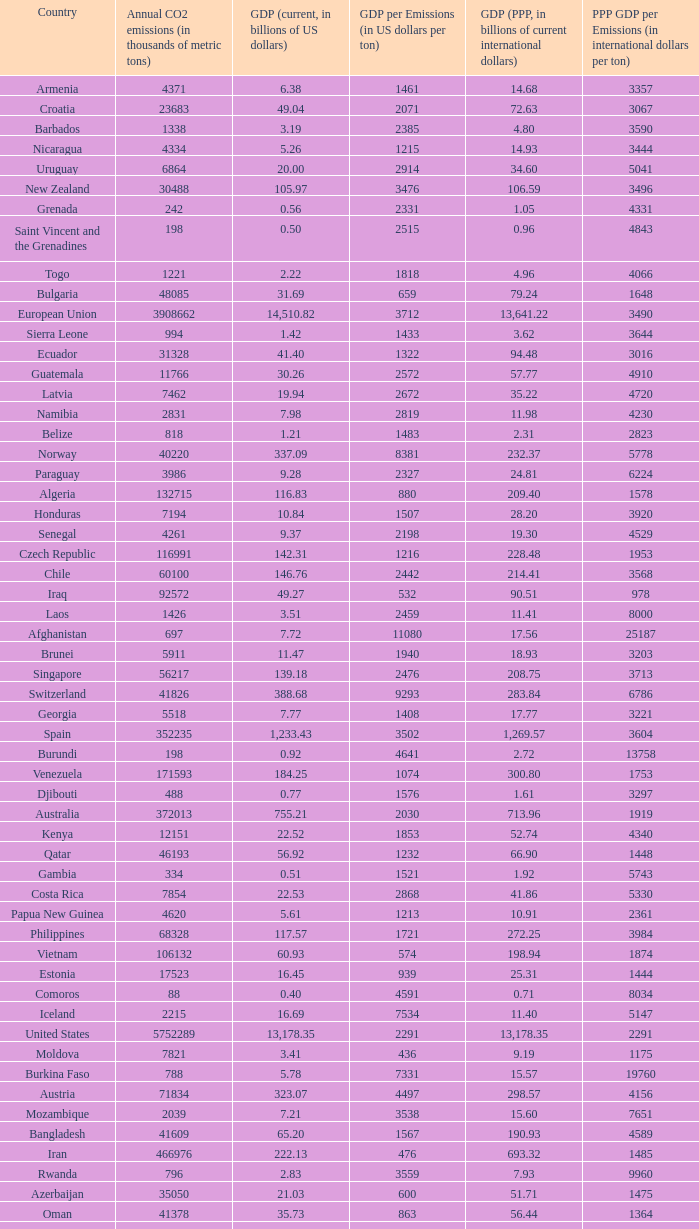Parse the full table. {'header': ['Country', 'Annual CO2 emissions (in thousands of metric tons)', 'GDP (current, in billions of US dollars)', 'GDP per Emissions (in US dollars per ton)', 'GDP (PPP, in billions of current international dollars)', 'PPP GDP per Emissions (in international dollars per ton)'], 'rows': [['Armenia', '4371', '6.38', '1461', '14.68', '3357'], ['Croatia', '23683', '49.04', '2071', '72.63', '3067'], ['Barbados', '1338', '3.19', '2385', '4.80', '3590'], ['Nicaragua', '4334', '5.26', '1215', '14.93', '3444'], ['Uruguay', '6864', '20.00', '2914', '34.60', '5041'], ['New Zealand', '30488', '105.97', '3476', '106.59', '3496'], ['Grenada', '242', '0.56', '2331', '1.05', '4331'], ['Saint Vincent and the Grenadines', '198', '0.50', '2515', '0.96', '4843'], ['Togo', '1221', '2.22', '1818', '4.96', '4066'], ['Bulgaria', '48085', '31.69', '659', '79.24', '1648'], ['European Union', '3908662', '14,510.82', '3712', '13,641.22', '3490'], ['Sierra Leone', '994', '1.42', '1433', '3.62', '3644'], ['Ecuador', '31328', '41.40', '1322', '94.48', '3016'], ['Guatemala', '11766', '30.26', '2572', '57.77', '4910'], ['Latvia', '7462', '19.94', '2672', '35.22', '4720'], ['Namibia', '2831', '7.98', '2819', '11.98', '4230'], ['Belize', '818', '1.21', '1483', '2.31', '2823'], ['Norway', '40220', '337.09', '8381', '232.37', '5778'], ['Paraguay', '3986', '9.28', '2327', '24.81', '6224'], ['Algeria', '132715', '116.83', '880', '209.40', '1578'], ['Honduras', '7194', '10.84', '1507', '28.20', '3920'], ['Senegal', '4261', '9.37', '2198', '19.30', '4529'], ['Czech Republic', '116991', '142.31', '1216', '228.48', '1953'], ['Chile', '60100', '146.76', '2442', '214.41', '3568'], ['Iraq', '92572', '49.27', '532', '90.51', '978'], ['Laos', '1426', '3.51', '2459', '11.41', '8000'], ['Afghanistan', '697', '7.72', '11080', '17.56', '25187'], ['Brunei', '5911', '11.47', '1940', '18.93', '3203'], ['Singapore', '56217', '139.18', '2476', '208.75', '3713'], ['Switzerland', '41826', '388.68', '9293', '283.84', '6786'], ['Georgia', '5518', '7.77', '1408', '17.77', '3221'], ['Spain', '352235', '1,233.43', '3502', '1,269.57', '3604'], ['Burundi', '198', '0.92', '4641', '2.72', '13758'], ['Venezuela', '171593', '184.25', '1074', '300.80', '1753'], ['Djibouti', '488', '0.77', '1576', '1.61', '3297'], ['Australia', '372013', '755.21', '2030', '713.96', '1919'], ['Kenya', '12151', '22.52', '1853', '52.74', '4340'], ['Qatar', '46193', '56.92', '1232', '66.90', '1448'], ['Gambia', '334', '0.51', '1521', '1.92', '5743'], ['Costa Rica', '7854', '22.53', '2868', '41.86', '5330'], ['Papua New Guinea', '4620', '5.61', '1213', '10.91', '2361'], ['Philippines', '68328', '117.57', '1721', '272.25', '3984'], ['Vietnam', '106132', '60.93', '574', '198.94', '1874'], ['Estonia', '17523', '16.45', '939', '25.31', '1444'], ['Comoros', '88', '0.40', '4591', '0.71', '8034'], ['Iceland', '2215', '16.69', '7534', '11.40', '5147'], ['United States', '5752289', '13,178.35', '2291', '13,178.35', '2291'], ['Moldova', '7821', '3.41', '436', '9.19', '1175'], ['Burkina Faso', '788', '5.78', '7331', '15.57', '19760'], ['Austria', '71834', '323.07', '4497', '298.57', '4156'], ['Mozambique', '2039', '7.21', '3538', '15.60', '7651'], ['Bangladesh', '41609', '65.20', '1567', '190.93', '4589'], ['Iran', '466976', '222.13', '476', '693.32', '1485'], ['Rwanda', '796', '2.83', '3559', '7.93', '9960'], ['Azerbaijan', '35050', '21.03', '600', '51.71', '1475'], ['Oman', '41378', '35.73', '863', '56.44', '1364'], ['Ethiopia', '6006', '15.17', '2525', '54.39', '9055'], ['Haiti', '1811', '4.84', '2670', '10.52', '5809'], ['Russia', '1564669', '989.43', '632', '1,887.61', '1206'], ['Seychelles', '744', '0.97', '1301', '1.61', '2157'], ['Netherlands', '168513', '677.96', '4023', '609.87', '3619'], ['India', '1510351', '874.77', '579', '2,672.66', '1770'], ['Romania', '98490', '122.70', '1246', '226.51', '2300'], ['Luxembourg', '11277', '42.59', '3777', '36.02', '3194'], ['Benin', '3109', '4.74', '1524', '11.29', '3631'], ['Brazil', '352524', '1,089.30', '3090', '1,700.57', '4824'], ['South Korea', '475248', '952.03', '2003', '1,190.70', '2505'], ['Cyprus', '7788', '18.43', '2366', '19.99', '2566'], ['Uganda', '2706', '9.96', '3680', '29.58', '10930'], ['Democratic Republic of the Congo', '2200', '8.79', '3993', '17.43', '7924'], ['Kuwait', '86599', '101.56', '1173', '119.96', '1385'], ['Mauritius', '3850', '6.32', '1641', '13.09', '3399'], ['Colombia', '63422', '162.50', '2562', '342.77', '5405'], ['Madagascar', '2834', '5.52', '1947', '16.84', '5943'], ['Macedonia', '10875', '6.38', '587', '16.14', '1484'], ['Syria', '68460', '33.51', '489', '82.09', '1199'], ['Portugal', '60001', '195.19', '3253', '220.57', '3676'], ['Guinea', '1360', '2.90', '2135', '9.29', '6829'], ['Bahrain', '21292', '15.85', '744', '22.41', '1053'], ['Yemen', '21201', '19.06', '899', '49.21', '2321'], ['Germany', '805090', '2,914.99', '3621', '2,671.45', '3318'], ['Niger', '935', '3.65', '3903', '8.56', '9157'], ['Suriname', '2438', '2.14', '878', '3.76', '1543'], ['Lebanon', '15330', '22.44', '1464', '40.46', '2639'], ['Botswana', '4770', '11.30', '2369', '23.51', '4929'], ['Timor-Leste', '176', '0.33', '1858', '1.96', '11153'], ['South Africa', '414649', '257.89', '622', '433.51', '1045'], ['Hungary', '57644', '113.05', '1961', '183.84', '3189'], ['Malta', '2548', '6.44', '2528', '8.88', '3485'], ['Turkey', '269452', '529.19', '1964', '824.58', '3060'], ['France', '383148', '2,271.28', '5928', '1,974.39', '5153'], ['Thailand', '272521', '206.99', '760', '483.56', '1774'], ['Mali', '568', '6.13', '10789', '13.10', '23055'], ['Mexico', '436150', '952.34', '2184', '1,408.81', '3230'], ['Egypt', '166800', '107.38', '644', '367.64', '2204'], ['Dominica', '117', '0.32', '2709', '0.66', '5632'], ['Greece', '96382', '267.71', '2778', '303.60', '3150'], ['Tunisia', '23126', '31.11', '1345', '70.57', '3052'], ['Vanuatu', '92', '0.42', '4522', '0.83', '9065'], ['Zimbabwe', '11081', '5.60', '505', '2.29', '207'], ['Jordan', '20724', '14.84', '716', '26.25', '1266'], ['Belgium', '107199', '400.30', '3734', '358.02', '3340'], ['Malawi', '1049', '3.15', '2998', '9.11', '8685'], ['Guyana', '1507', '0.91', '606', '2.70', '1792'], ['Bolivia', '6973', '11.53', '1653', '37.37', '5359'], ['Cameroon', '3645', '17.96', '4926', '37.14', '10189'], ['Dominican Republic', '20357', '35.28', '1733', '63.94', '3141'], ['Denmark', '53944', '274.11', '5081', '193.54', '3588'], ['Fiji', '1610', '3.17', '1967', '3.74', '2320'], ['Swaziland', '1016', '2.67', '2629', '5.18', '5095'], ['Nepal', '3241', '9.03', '2787', '27.86', '8595'], ['Equatorial Guinea', '4356', '9.60', '2205', '15.76', '3618'], ['Kyrgyzstan', '5566', '2.84', '510', '9.45', '1698'], ['Canada', '544680', '1,278.97', '2348', '1,203.74', '2210'], ['Bhutan', '381', '0.93', '2444', '2.61', '6850'], ['Slovenia', '15173', '38.94', '2566', '51.14', '3370'], ['Antigua and Barbuda', '425', '1.01', '2367', '1.41', '3315'], ['Republic of the Congo', '1463', '7.74', '5289', '13.10', '8954'], ['Burma', '10025', '14.50', '1447', '55.55', '5541'], ['Samoa', '158', '0.43', '2747', '0.95', '5987'], ['Guinea-Bissau', '279', '0.32', '1136', '0.76', '2724'], ['Poland', '318219', '341.67', '1074', '567.94', '1785'], ['Mauritania', '1665', '2.70', '1621', '5.74', '3448'], ['Peru', '38643', '92.31', '2389', '195.99', '5072'], ['United Arab Emirates', '139553', '164.17', '1176', '154.35', '1106'], ['Malaysia', '187865', '156.86', '835', '328.97', '1751'], ['Morocco', '45316', '65.64', '1448', '120.32', '2655'], ['Pakistan', '142659', '127.49', '894', '372.96', '2614'], ['El Salvador', '6461', '18.65', '2887', '38.79', '6004'], ['Finland', '66693', '209.71', '3144', '172.98', '2594'], ['Italy', '474148', '1,865.11', '3934', '1,720.64', '3629'], ['Liberia', '785', '0.61', '780', '1.19', '1520'], ['Eritrea', '554', '1.21', '2186', '3.48', '6283'], ['United Kingdom', '568520', '2,435.70', '4284', '2,048.99', '3604'], ['Sri Lanka', '11876', '28.28', '2381', '77.51', '6526'], ['Belarus', '68849', '36.96', '537', '94.80', '1377'], ['Ivory Coast', '6882', '17.38', '2526', '31.22', '4536'], ['Sweden', '50875', '393.76', '7740', '318.42', '6259'], ['Zambia', '2471', '10.89', '4408', '14.74', '5965'], ['Indonesia', '333483', '364.35', '1093', '767.92', '2303'], ['Sudan', '10813', '36.40', '3366', '71.17', '6581'], ['Solomon Islands', '180', '0.33', '1856', '0.86', '4789'], ['Lithuania', '14190', '30.08', '2120', '54.04', '3808'], ['Tajikistan', '6391', '2.81', '440', '10.69', '1672'], ['Gabon', '2057', '9.55', '4641', '18.63', '9057'], ['Tanzania', '5372', '14.35', '2671', '44.46', '8276'], ['Serbia and Montenegro', '53266', '32.30', '606', '72.93', '1369'], ['Turkmenistan', '44103', '21.40', '485', '23.40', '531'], ['Ghana', '9240', '12.73', '1378', '28.72', '3108'], ['Israel', '70440', '143.98', '2044', '174.61', '2479'], ['Saint Lucia', '367', '0.93', '2520', '1.69', '4616'], ['Saint Kitts and Nevis', '136', '0.49', '3588', '0.68', '4963'], ['Kiribati', '29', '0.11', '3690', '0.56', '19448'], ['Libya', '55495', '55.08', '992', '75.47', '1360'], ['Tonga', '132', '0.24', '1788', '0.54', '4076'], ['Ukraine', '319158', '108.00', '338', '291.30', '913'], ['Angola', '10582', '45.17', '4268', '73.45', '6941'], ['Japan', '1293409', '4,363.63', '3374', '4,079.14', '3154'], ['Cape Verde', '308', '1.20', '3906', '1.47', '4776'], ['Cambodia', '4074', '7.26', '1783', '23.03', '5653'], ['Saudi Arabia', '381564', '356.63', '935', '522.12', '1368'], ['Central African Republic', '249', '1.48', '5924', '2.89', '11618'], ['Ireland', '43806', '222.61', '5082', '173.01', '3949'], ['Bahamas', '2138', '6.88', '3216', '8.67', '4053'], ['Trinidad and Tobago', '33601', '19.38', '577', '23.62', '703'], ['São Tomé and Príncipe', '103', '0.13', '1214', '0.24', '2311'], ['Albania', '4301', '9.11', '2119', '18.34', '4264'], ['Slovakia', '37459', '56.00', '1495', '96.76', '2583'], ['Chad', '396', '6.31', '15924', '15.40', '38881'], ['Jamaica', '12151', '11.45', '942', '19.93', '1640'], ['Kazakhstan', '193508', '81.00', '419', '150.56', '778'], ['Hong Kong', '39039', '189.93', '4865', '268.53', '6878'], ['China', '6103493', '2,657.84', '435', '6,122.24', '1003'], ['Maldives', '869', '0.92', '1053', '1.44', '1654'], ['Argentina', '173536', '212.71', '1226', '469.75', '2707'], ['Mongolia', '9442', '3.16', '334', '7.47', '791'], ['Bosnia and Herzegovina', '27438', '12.28', '447', '25.70', '937'], ['Nigeria', '97262', '146.89', '1510', '268.21', '2758'], ['Panama', '6428', '17.13', '2666', '30.21', '4700']]} When the gdp per emissions (in us dollars per ton) is 3903, what is the maximum annual co2 emissions (in thousands of metric tons)? 935.0. 